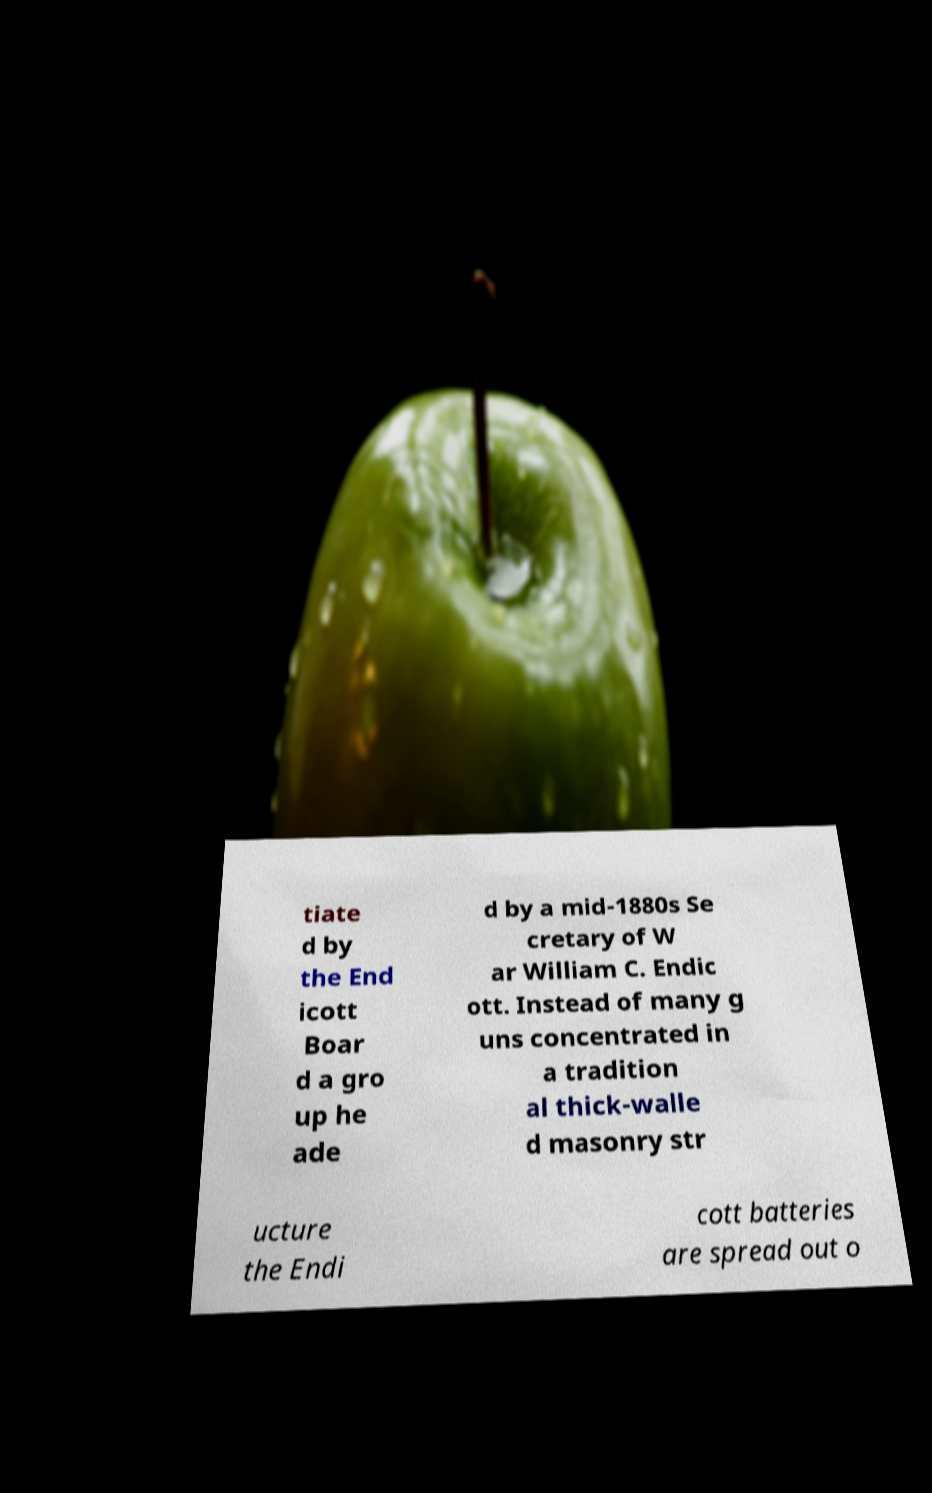I need the written content from this picture converted into text. Can you do that? tiate d by the End icott Boar d a gro up he ade d by a mid-1880s Se cretary of W ar William C. Endic ott. Instead of many g uns concentrated in a tradition al thick-walle d masonry str ucture the Endi cott batteries are spread out o 